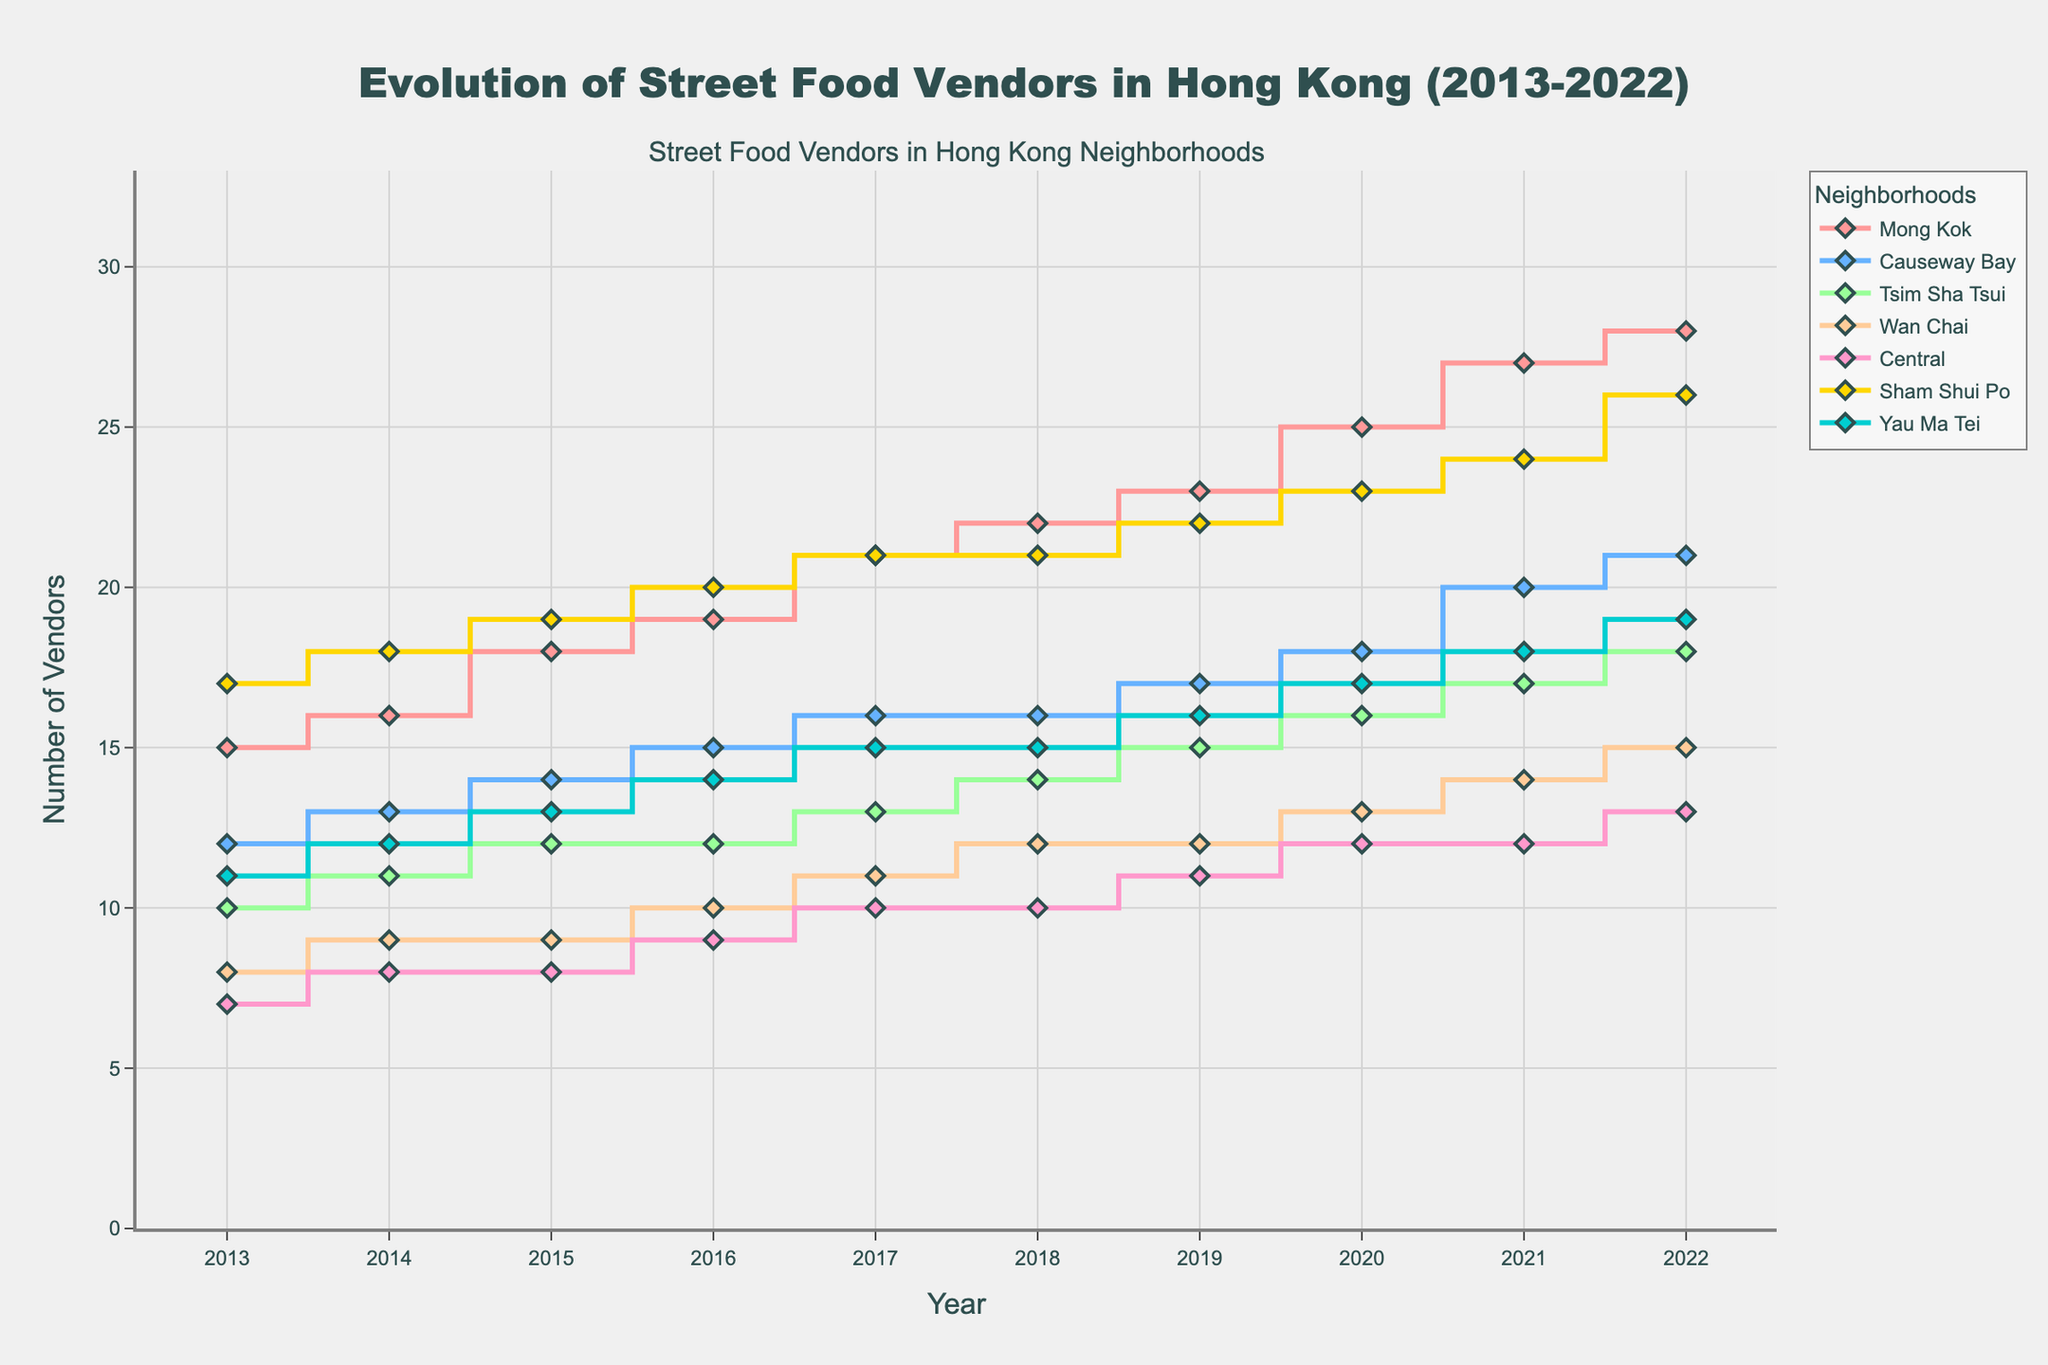What is the title of the figure? The title of the figure is found at the top center and it provides a summary of what the plot is about. It reads "Evolution of Street Food Vendors in Hong Kong (2013-2022)"
Answer: Evolution of Street Food Vendors in Hong Kong (2013-2022) How many neighborhoods are represented in the plot? Each neighborhood is represented by a different line in the plot. By counting these lines or checking the legend, one can determine the number of neighborhoods. There are 7 neighborhoods listed in the legend.
Answer: 7 Which neighborhood had the highest number of street food vendors in 2022? To find this, check the value at the year 2022 for all the neighborhoods and compare. Mong Kok has the highest value with 28 vendors.
Answer: Mong Kok Did any neighborhoods have the same number of street food vendors at any point during the decade? Look for overlapping points or equal y-values on the vertical axis for different neighborhoods. In 2016, both Wan Chai and Central had 10 vendors.
Answer: Yes, Wan Chai and Central in 2016 Which neighborhood had the most significant increase in the number of vendors over the ten years? Calculate the difference between 2022 and 2013 for each neighborhood. Mong Kok increased from 15 to 28 vendors, a difference of 13, which is the highest.
Answer: Mong Kok How many vendors were there in Sham Shui Po in 2018? Locate the line corresponding to Sham Shui Po, find the point at 2018, and read the value. Sham Shui Po had 21 vendors in 2018.
Answer: 21 What is the average number of vendors in Yau Ma Tei over the decade? Sum the values from 2013 to 2022 for Yau Ma Tei and then divide by the number of years (10). The sum is (11+12+13+14+15+15+16+17+18+19) = 150. Therefore, the average is 150/10 = 15.
Answer: 15 Which two years showed the same number of vendors for Causeway Bay? Look at the plot for Causeway Bay and identify any horizontal segments. Both 2017 and 2018 show 16 vendors.
Answer: 2017 and 2018 What trend do you observe in the number of vendors in Central from 2013 to 2022? The number of vendors shows an overall increasing trend when moving from left (2013) to right (2022). It starts at 7 in 2013 and gradually increases to 13 in 2022.
Answer: Increasing trend How does the number of vendors in Wan Chai in 2022 compare to that in Tsim Sha Tsui in 2018? Check the values for Wan Chai in 2022 and Tsim Sha Tsui in 2018 and compare them. Wan Chai had 15 vendors in 2022, and Tsim Sha Tsui had 14 vendors in 2018.
Answer: Wan Chai in 2022 had 1 more vendor than Tsim Sha Tsui in 2018 